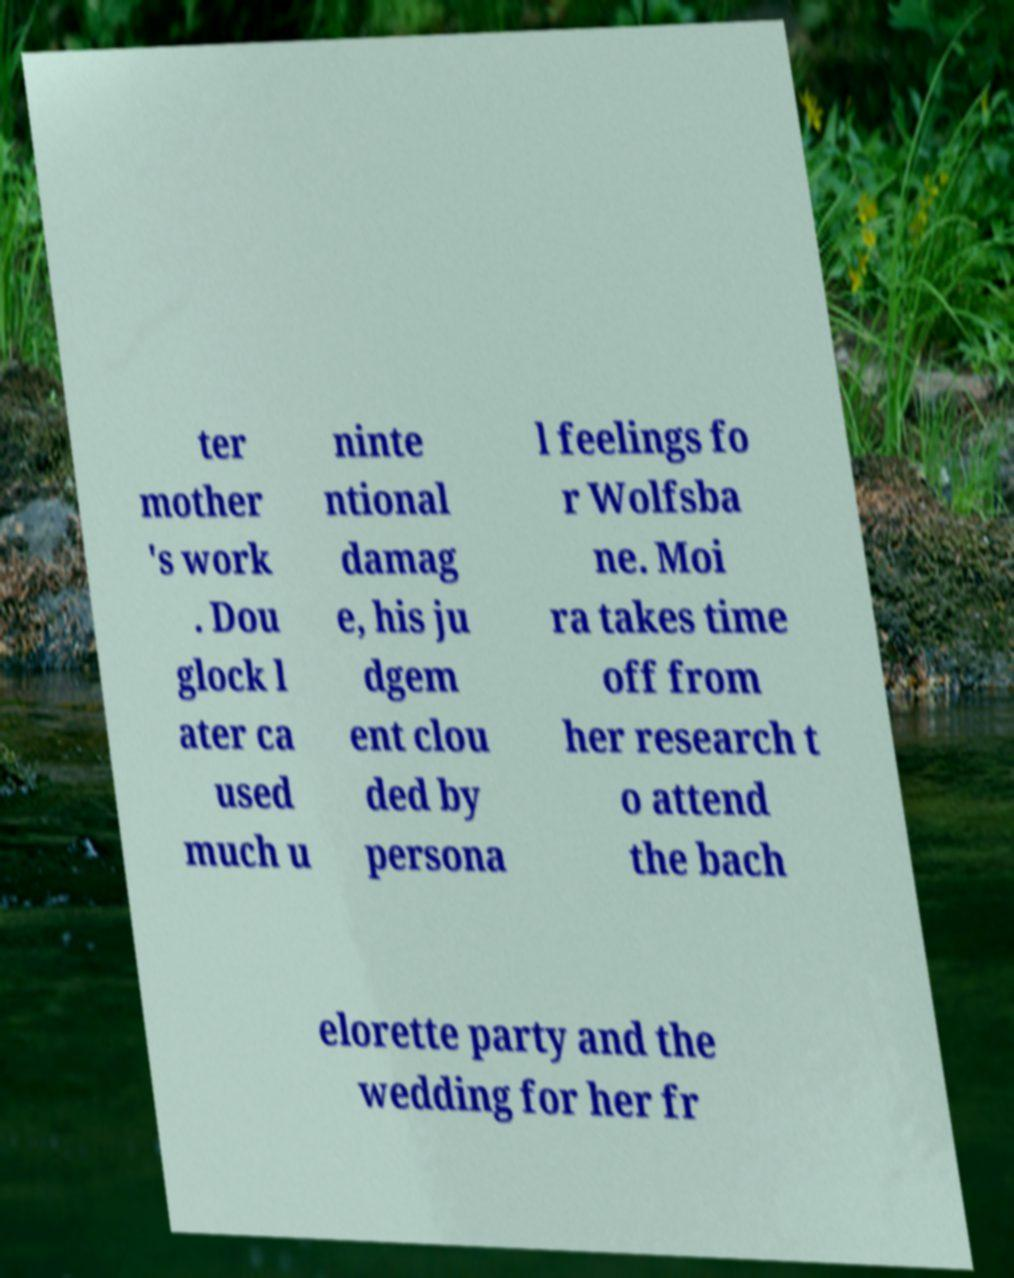There's text embedded in this image that I need extracted. Can you transcribe it verbatim? ter mother 's work . Dou glock l ater ca used much u ninte ntional damag e, his ju dgem ent clou ded by persona l feelings fo r Wolfsba ne. Moi ra takes time off from her research t o attend the bach elorette party and the wedding for her fr 